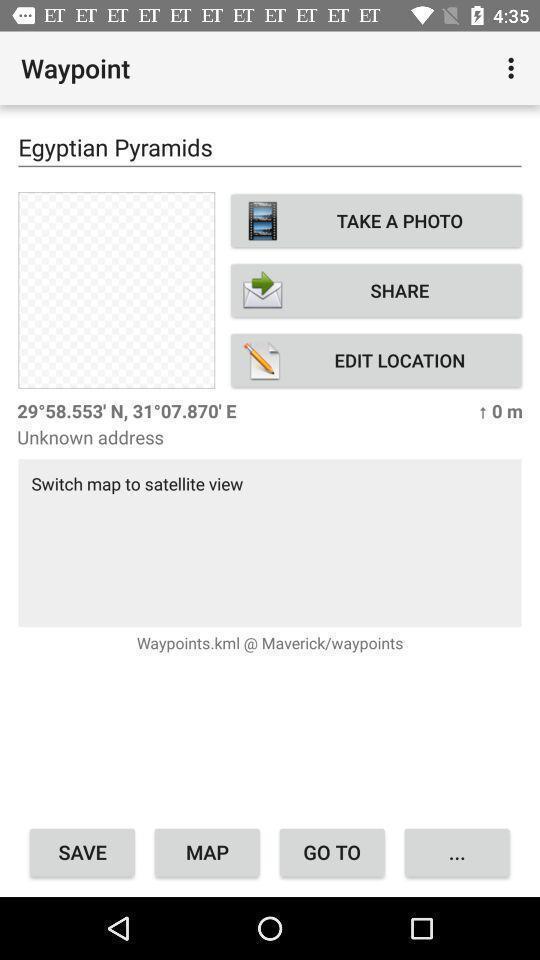Summarize the main components in this picture. Screen displaying multiple options in a tracking application. 